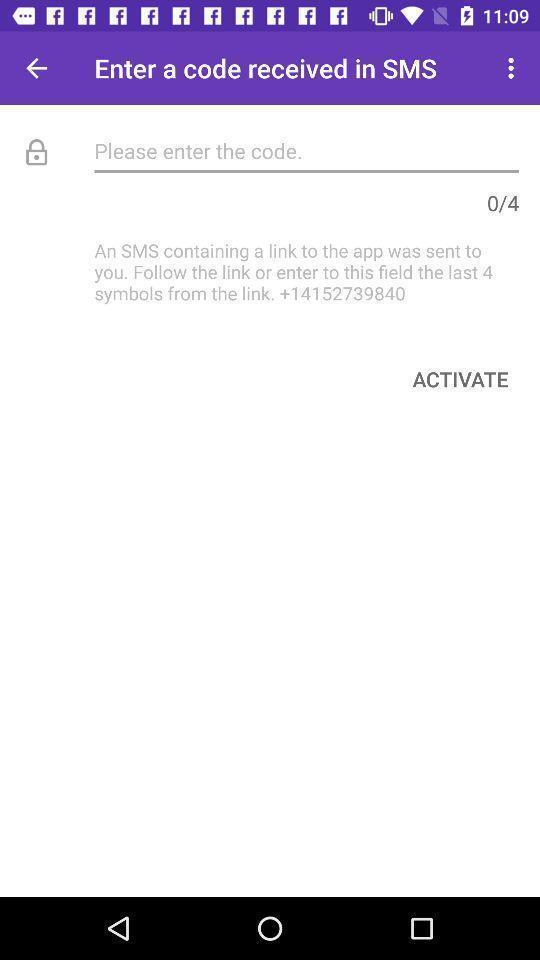Tell me about the visual elements in this screen capture. Sms verification page of a social app. 